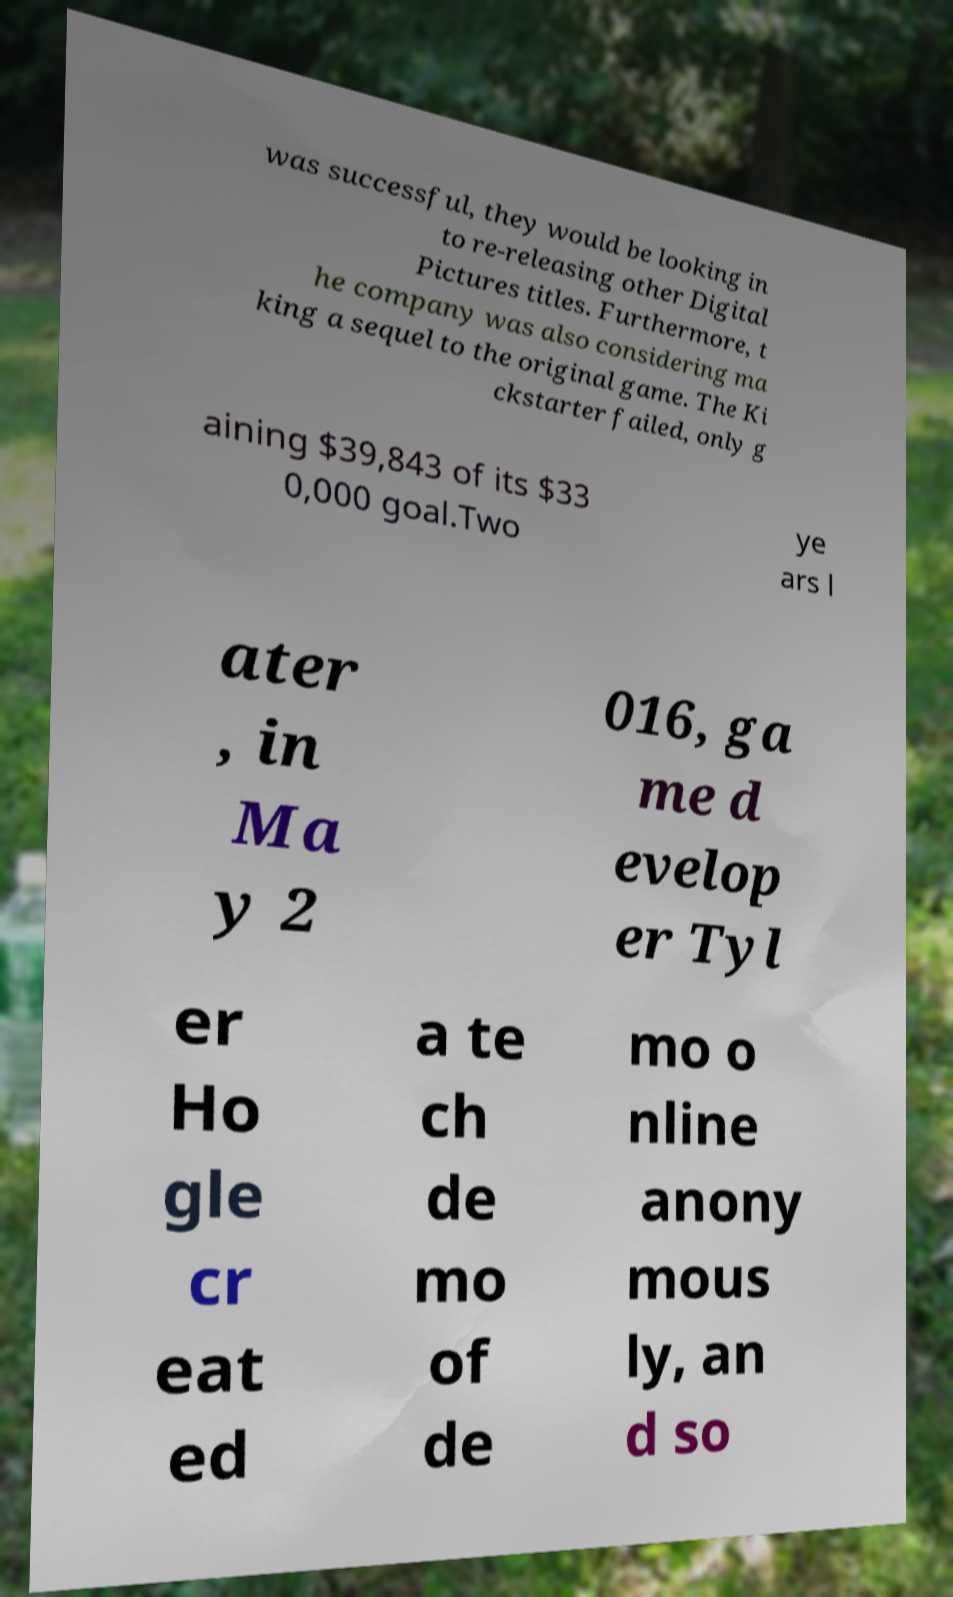I need the written content from this picture converted into text. Can you do that? was successful, they would be looking in to re-releasing other Digital Pictures titles. Furthermore, t he company was also considering ma king a sequel to the original game. The Ki ckstarter failed, only g aining $39,843 of its $33 0,000 goal.Two ye ars l ater , in Ma y 2 016, ga me d evelop er Tyl er Ho gle cr eat ed a te ch de mo of de mo o nline anony mous ly, an d so 